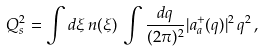Convert formula to latex. <formula><loc_0><loc_0><loc_500><loc_500>Q _ { s } ^ { 2 } = \int d \xi \, n ( \xi ) \, \int \frac { d { q } } { ( 2 \pi ) ^ { 2 } } | a _ { a } ^ { + } ( { q } ) | ^ { 2 } \, { q } ^ { 2 } \, ,</formula> 